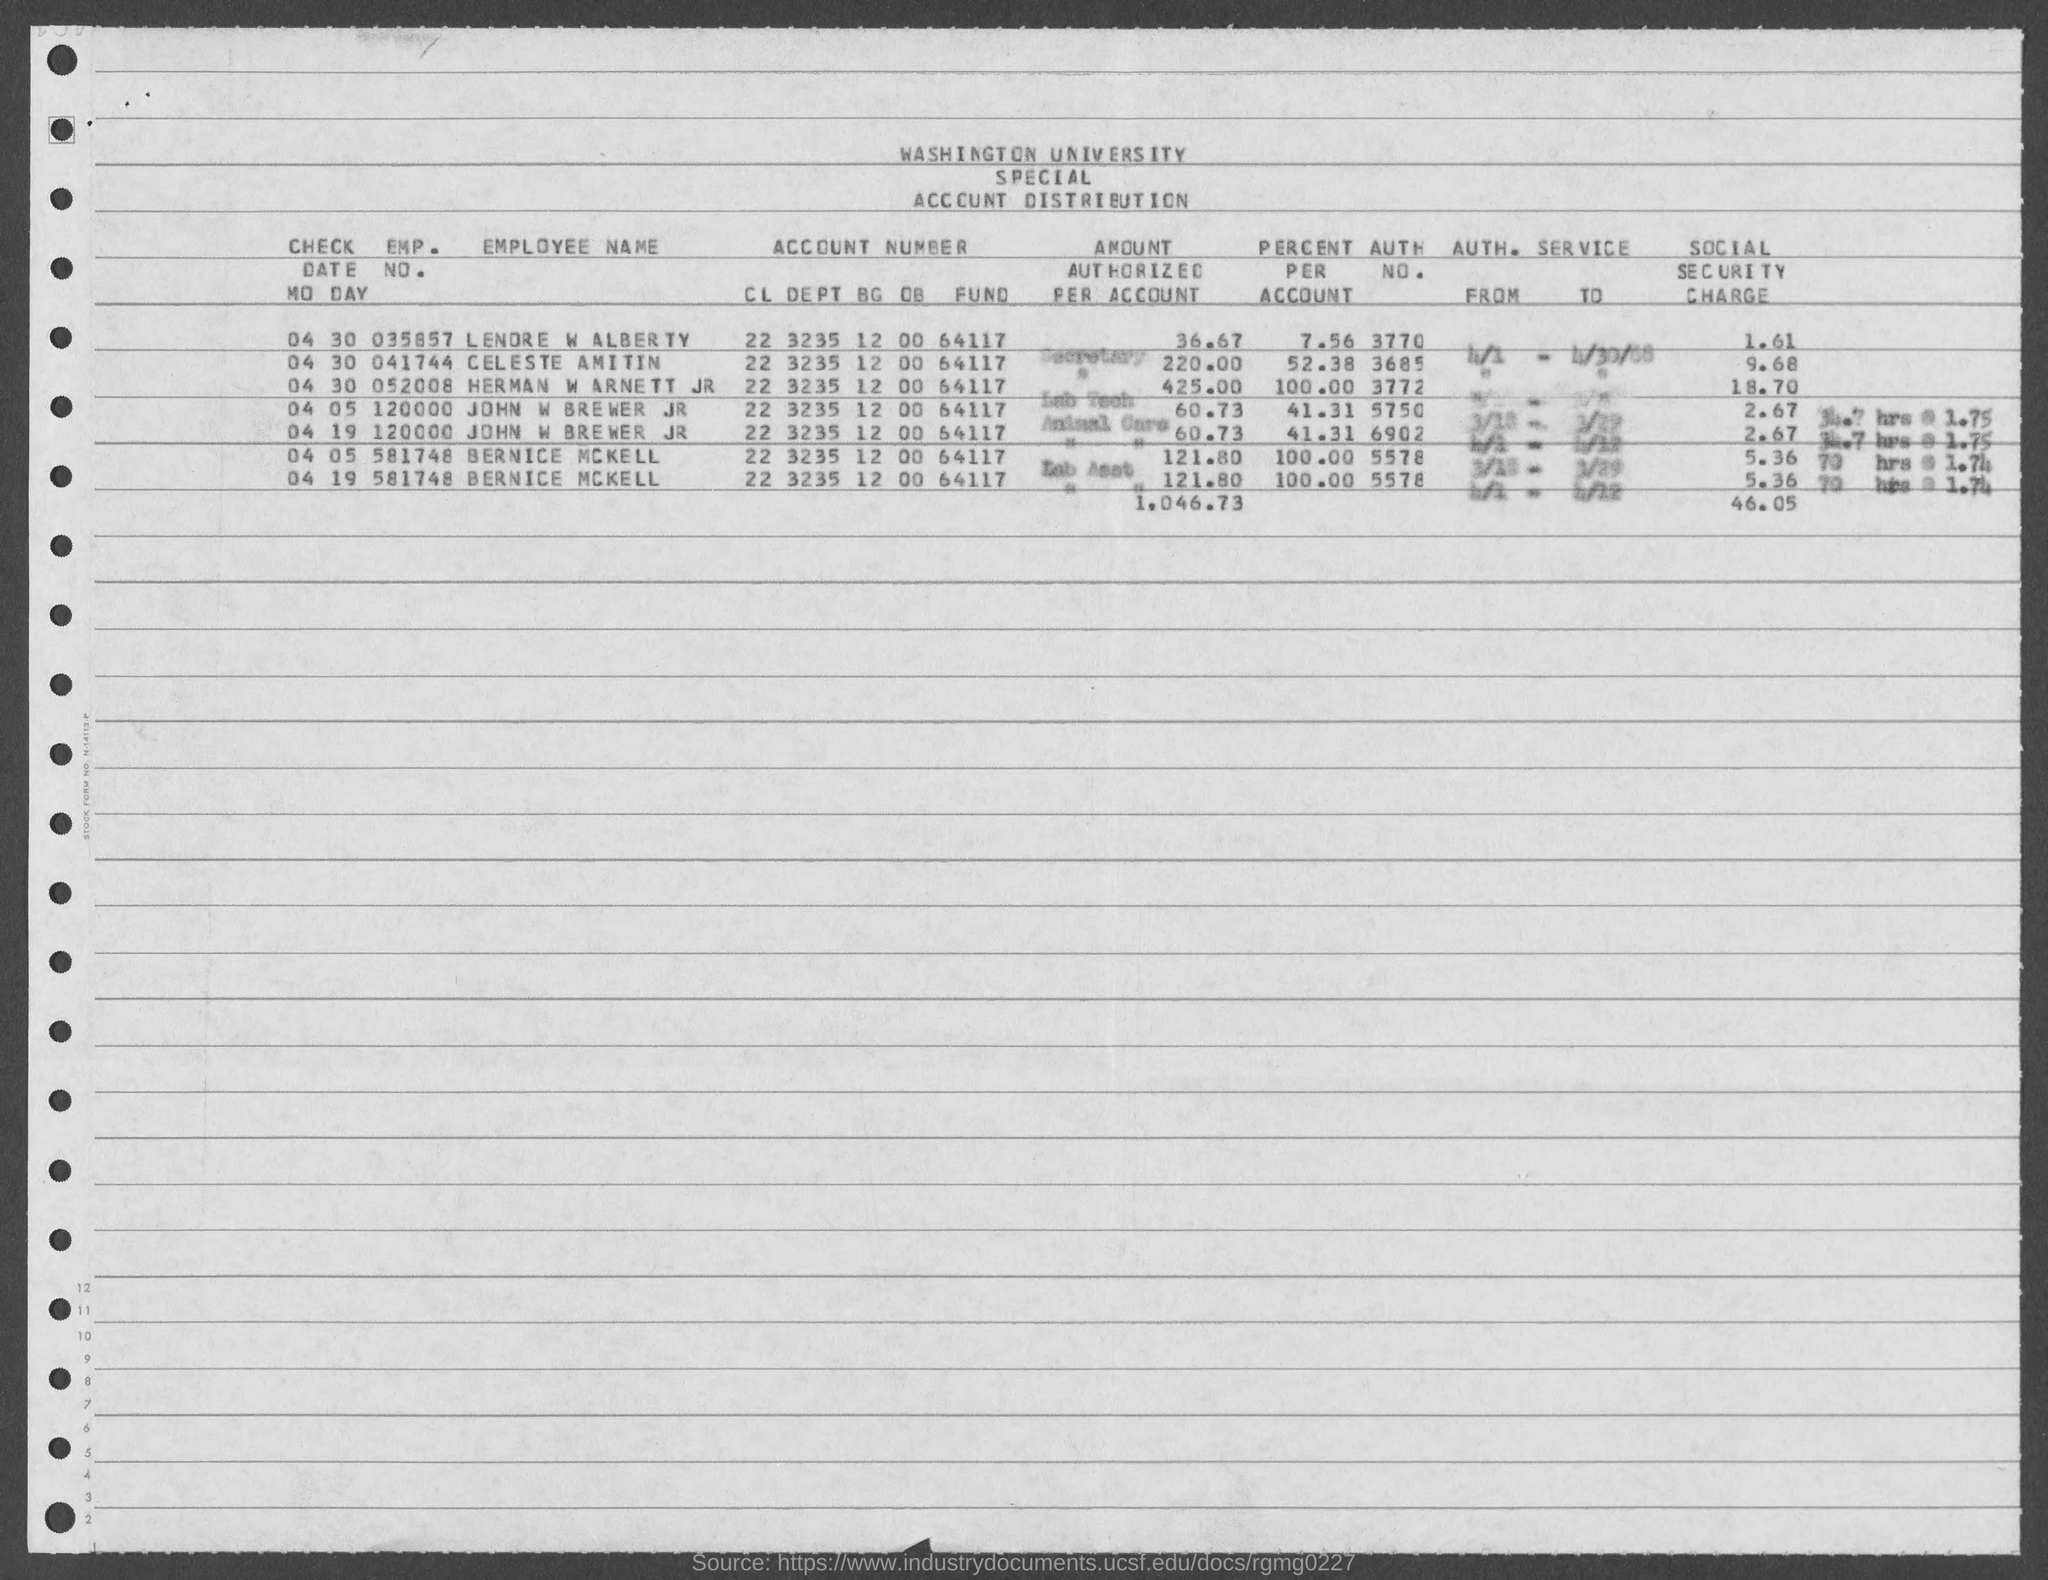Point out several critical features in this image. Bernice McKell's account number is 2232351200064117 The employee number of Lendre W Alber TV is 035857. 